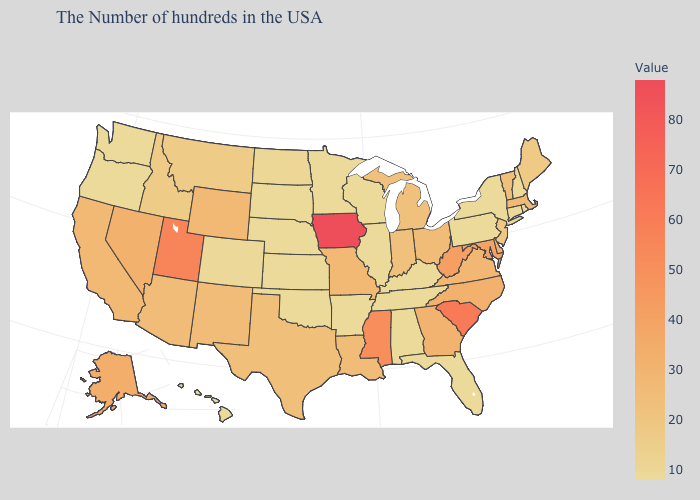Which states hav the highest value in the South?
Short answer required. South Carolina. Does Georgia have the lowest value in the USA?
Answer briefly. No. Does Hawaii have the highest value in the West?
Write a very short answer. No. Does Ohio have the lowest value in the USA?
Write a very short answer. No. Does South Dakota have the lowest value in the USA?
Short answer required. Yes. Among the states that border Iowa , does Nebraska have the highest value?
Be succinct. No. Does Idaho have the lowest value in the West?
Quick response, please. No. 